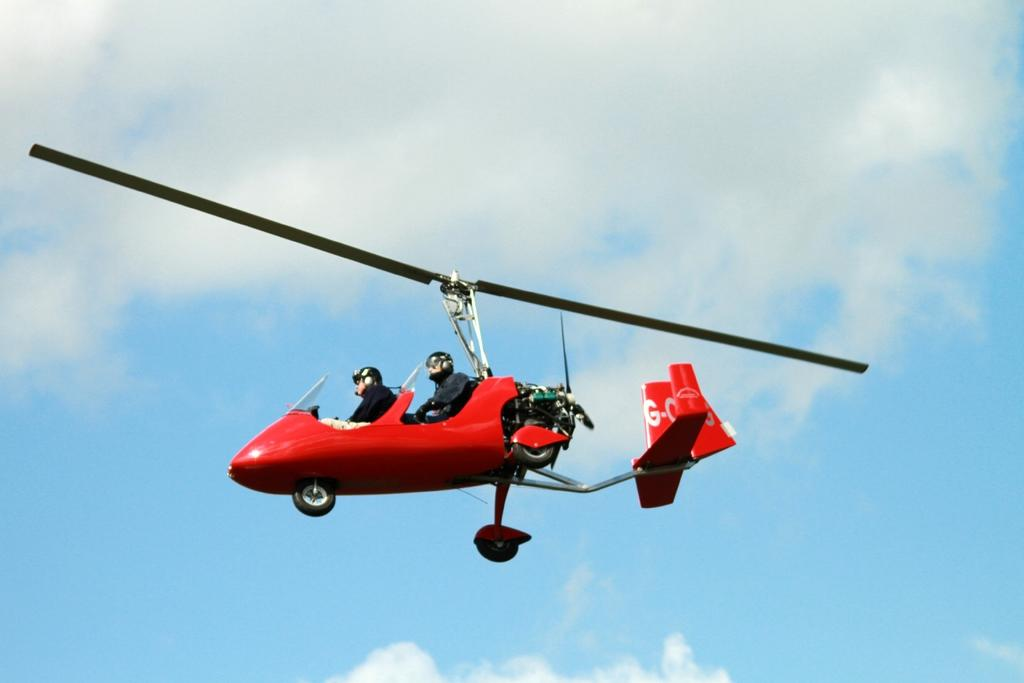How many people are in the image? There are two people in the image. What are the two people doing in the image? The two people are sitting in a helicopter. What is the helicopter doing in the image? The helicopter is flying in the sky. What type of straw is being used by the people in the image? There is no straw present in the image; the two people are sitting in a helicopter. How does the neck of the helicopter look like in the image? The image does not show the neck of the helicopter, as it only shows the two people sitting inside the helicopter. 